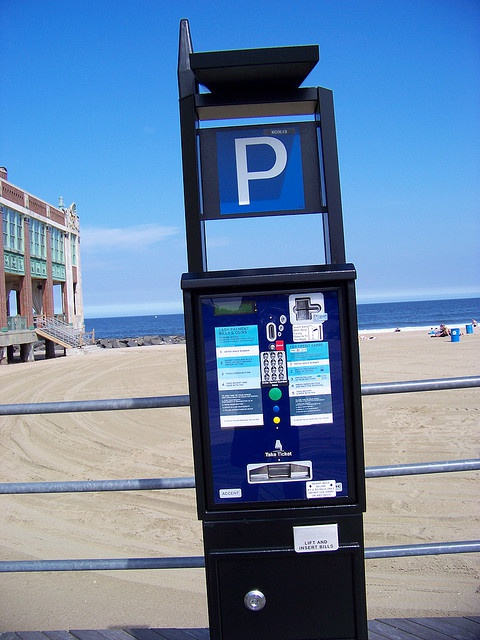Describe the objects in this image and their specific colors. I can see parking meter in blue, black, navy, lightblue, and white tones, people in blue, black, brown, salmon, and purple tones, people in blue, lightgray, lightblue, and darkgray tones, people in blue, lightgray, darkgray, pink, and navy tones, and people in blue, purple, violet, and navy tones in this image. 